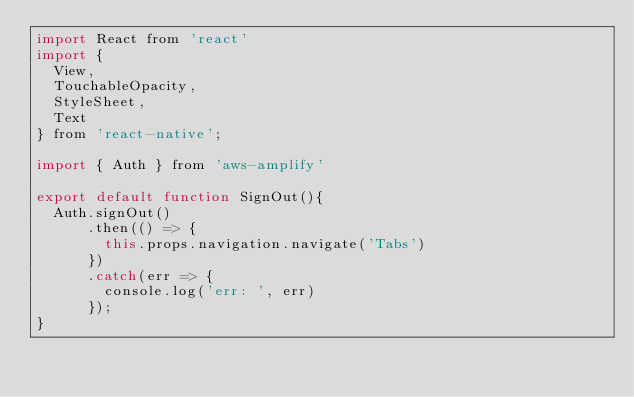Convert code to text. <code><loc_0><loc_0><loc_500><loc_500><_JavaScript_>import React from 'react'
import {
  View,
  TouchableOpacity,
  StyleSheet,
  Text
} from 'react-native';

import { Auth } from 'aws-amplify'

export default function SignOut(){
  Auth.signOut()
      .then(() => {
        this.props.navigation.navigate('Tabs')
      })
      .catch(err => {
        console.log('err: ', err)
      });
}
</code> 